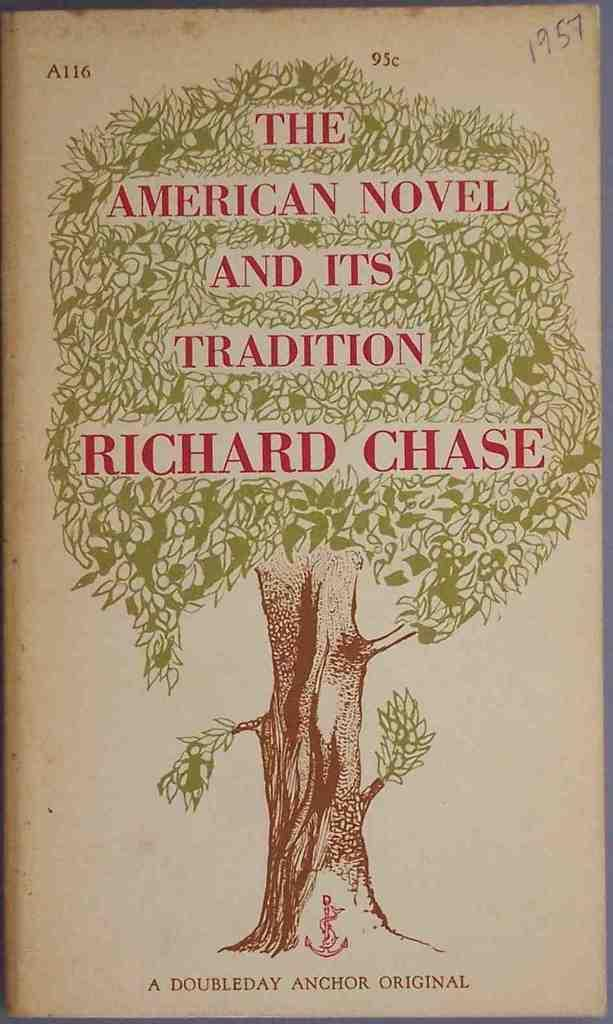<image>
Render a clear and concise summary of the photo. A book titled The American Novel and its Tradition 